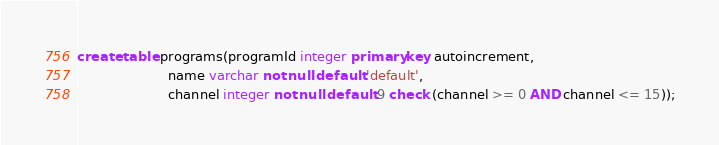<code> <loc_0><loc_0><loc_500><loc_500><_SQL_>create table programs(programId integer primary key autoincrement,
                      name varchar not null default 'default',
                      channel integer not null default 9 check (channel >= 0 AND channel <= 15));
</code> 